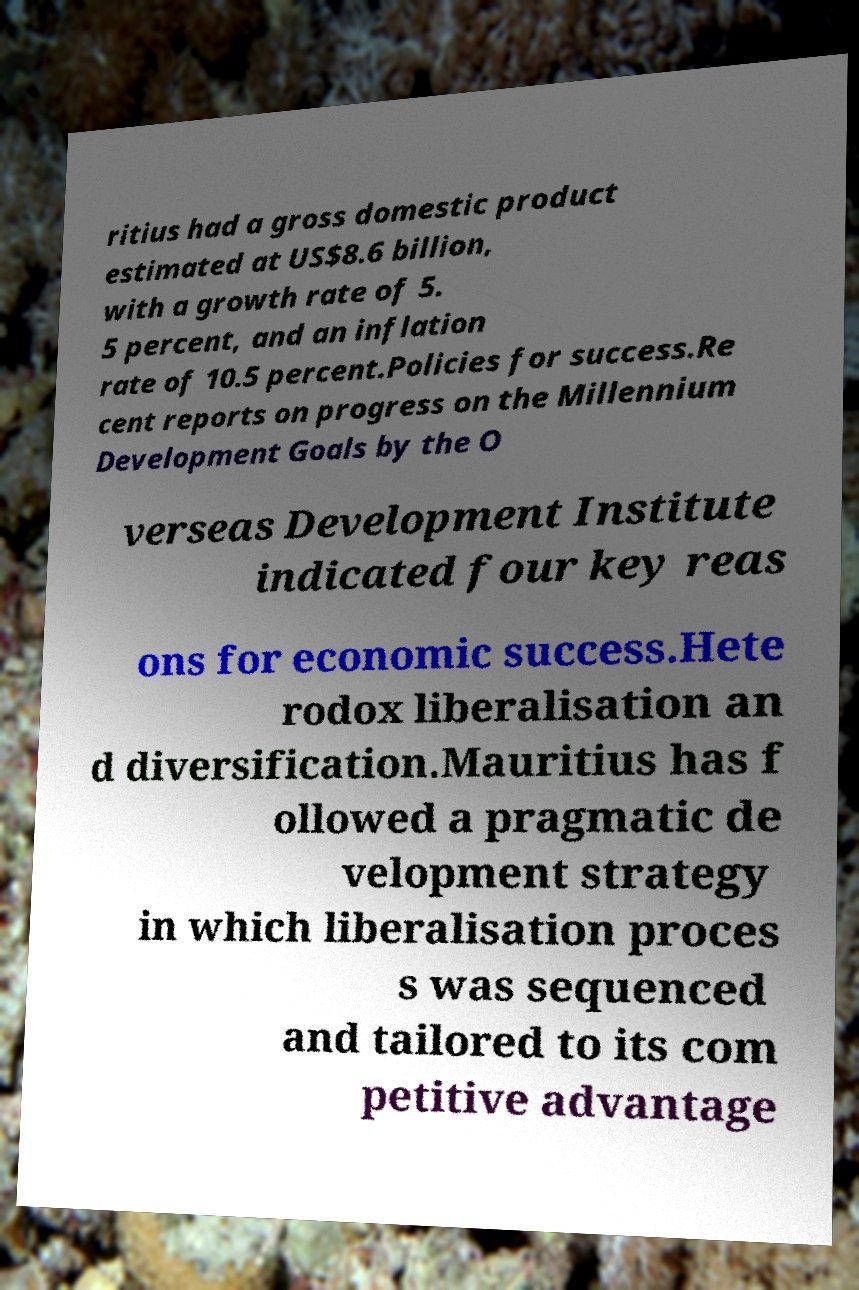Can you read and provide the text displayed in the image?This photo seems to have some interesting text. Can you extract and type it out for me? ritius had a gross domestic product estimated at US$8.6 billion, with a growth rate of 5. 5 percent, and an inflation rate of 10.5 percent.Policies for success.Re cent reports on progress on the Millennium Development Goals by the O verseas Development Institute indicated four key reas ons for economic success.Hete rodox liberalisation an d diversification.Mauritius has f ollowed a pragmatic de velopment strategy in which liberalisation proces s was sequenced and tailored to its com petitive advantage 